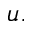Convert formula to latex. <formula><loc_0><loc_0><loc_500><loc_500>u .</formula> 